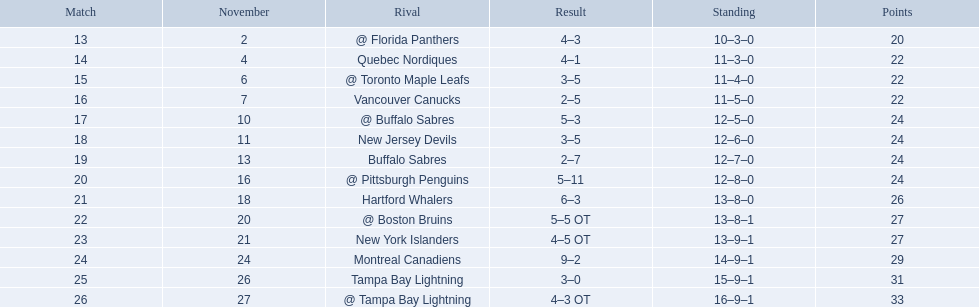What were the scores? @ Florida Panthers, 4–3, Quebec Nordiques, 4–1, @ Toronto Maple Leafs, 3–5, Vancouver Canucks, 2–5, @ Buffalo Sabres, 5–3, New Jersey Devils, 3–5, Buffalo Sabres, 2–7, @ Pittsburgh Penguins, 5–11, Hartford Whalers, 6–3, @ Boston Bruins, 5–5 OT, New York Islanders, 4–5 OT, Montreal Canadiens, 9–2, Tampa Bay Lightning, 3–0, @ Tampa Bay Lightning, 4–3 OT. What score was the closest? New York Islanders, 4–5 OT. What team had that score? New York Islanders. 